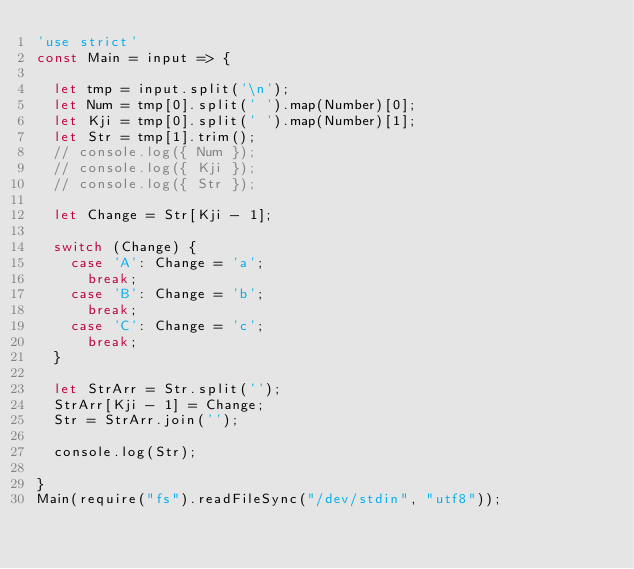Convert code to text. <code><loc_0><loc_0><loc_500><loc_500><_JavaScript_>'use strict'
const Main = input => {

  let tmp = input.split('\n');
  let Num = tmp[0].split(' ').map(Number)[0];
  let Kji = tmp[0].split(' ').map(Number)[1];
  let Str = tmp[1].trim();
  // console.log({ Num });
  // console.log({ Kji });
  // console.log({ Str });

  let Change = Str[Kji - 1];

  switch (Change) {
    case 'A': Change = 'a';
      break;
    case 'B': Change = 'b';
      break;
    case 'C': Change = 'c';
      break;
  }

  let StrArr = Str.split('');
  StrArr[Kji - 1] = Change;
  Str = StrArr.join('');

  console.log(Str);

}
Main(require("fs").readFileSync("/dev/stdin", "utf8"));</code> 